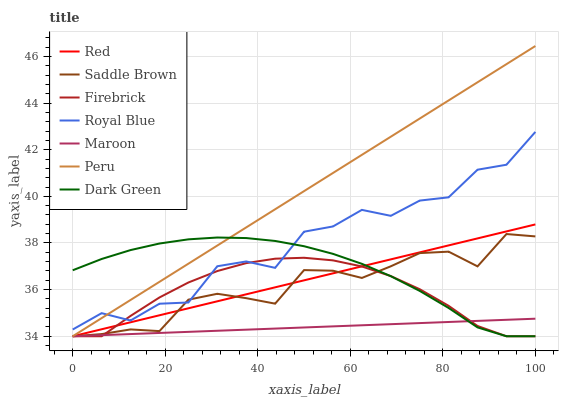Does Maroon have the minimum area under the curve?
Answer yes or no. Yes. Does Peru have the maximum area under the curve?
Answer yes or no. Yes. Does Royal Blue have the minimum area under the curve?
Answer yes or no. No. Does Royal Blue have the maximum area under the curve?
Answer yes or no. No. Is Peru the smoothest?
Answer yes or no. Yes. Is Royal Blue the roughest?
Answer yes or no. Yes. Is Maroon the smoothest?
Answer yes or no. No. Is Maroon the roughest?
Answer yes or no. No. Does Firebrick have the lowest value?
Answer yes or no. Yes. Does Royal Blue have the lowest value?
Answer yes or no. No. Does Peru have the highest value?
Answer yes or no. Yes. Does Royal Blue have the highest value?
Answer yes or no. No. Is Red less than Royal Blue?
Answer yes or no. Yes. Is Royal Blue greater than Maroon?
Answer yes or no. Yes. Does Red intersect Peru?
Answer yes or no. Yes. Is Red less than Peru?
Answer yes or no. No. Is Red greater than Peru?
Answer yes or no. No. Does Red intersect Royal Blue?
Answer yes or no. No. 